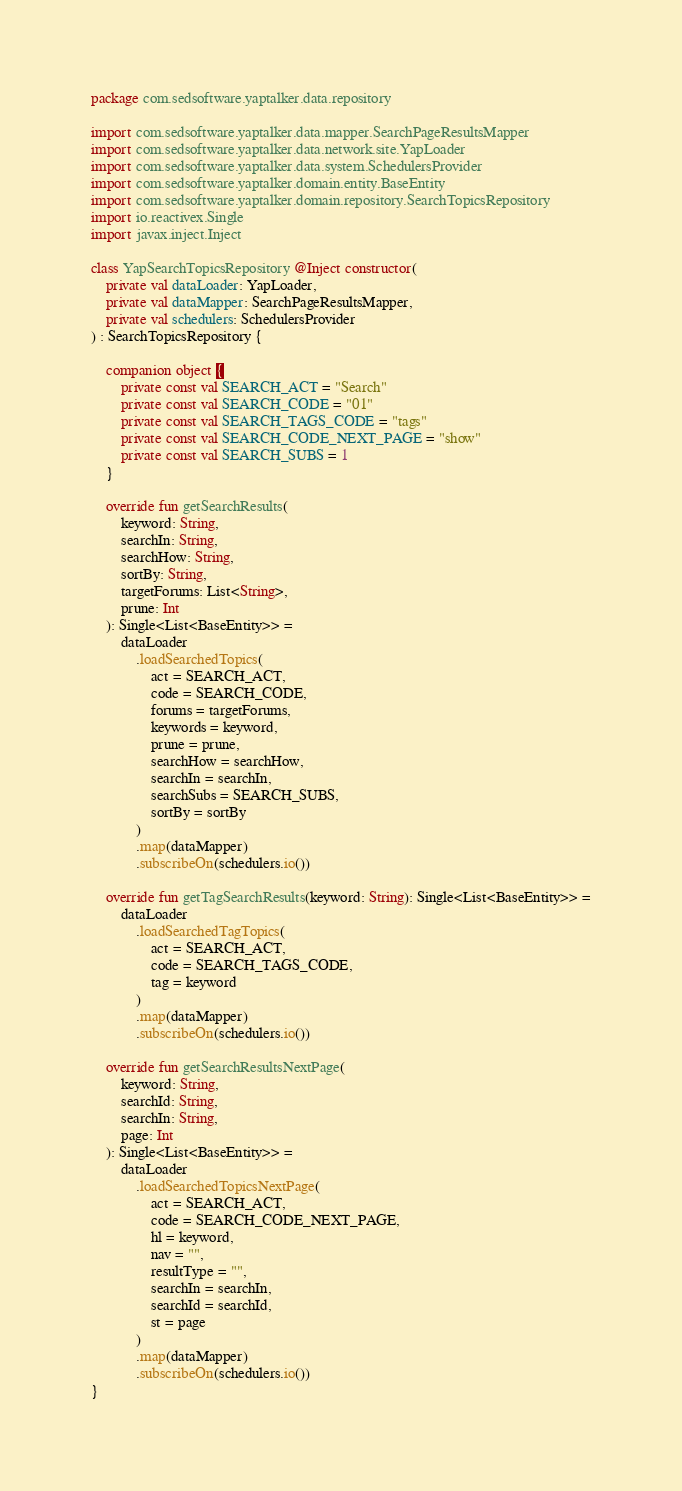<code> <loc_0><loc_0><loc_500><loc_500><_Kotlin_>package com.sedsoftware.yaptalker.data.repository

import com.sedsoftware.yaptalker.data.mapper.SearchPageResultsMapper
import com.sedsoftware.yaptalker.data.network.site.YapLoader
import com.sedsoftware.yaptalker.data.system.SchedulersProvider
import com.sedsoftware.yaptalker.domain.entity.BaseEntity
import com.sedsoftware.yaptalker.domain.repository.SearchTopicsRepository
import io.reactivex.Single
import javax.inject.Inject

class YapSearchTopicsRepository @Inject constructor(
    private val dataLoader: YapLoader,
    private val dataMapper: SearchPageResultsMapper,
    private val schedulers: SchedulersProvider
) : SearchTopicsRepository {

    companion object {
        private const val SEARCH_ACT = "Search"
        private const val SEARCH_CODE = "01"
        private const val SEARCH_TAGS_CODE = "tags"
        private const val SEARCH_CODE_NEXT_PAGE = "show"
        private const val SEARCH_SUBS = 1
    }

    override fun getSearchResults(
        keyword: String,
        searchIn: String,
        searchHow: String,
        sortBy: String,
        targetForums: List<String>,
        prune: Int
    ): Single<List<BaseEntity>> =
        dataLoader
            .loadSearchedTopics(
                act = SEARCH_ACT,
                code = SEARCH_CODE,
                forums = targetForums,
                keywords = keyword,
                prune = prune,
                searchHow = searchHow,
                searchIn = searchIn,
                searchSubs = SEARCH_SUBS,
                sortBy = sortBy
            )
            .map(dataMapper)
            .subscribeOn(schedulers.io())

    override fun getTagSearchResults(keyword: String): Single<List<BaseEntity>> =
        dataLoader
            .loadSearchedTagTopics(
                act = SEARCH_ACT,
                code = SEARCH_TAGS_CODE,
                tag = keyword
            )
            .map(dataMapper)
            .subscribeOn(schedulers.io())

    override fun getSearchResultsNextPage(
        keyword: String,
        searchId: String,
        searchIn: String,
        page: Int
    ): Single<List<BaseEntity>> =
        dataLoader
            .loadSearchedTopicsNextPage(
                act = SEARCH_ACT,
                code = SEARCH_CODE_NEXT_PAGE,
                hl = keyword,
                nav = "",
                resultType = "",
                searchIn = searchIn,
                searchId = searchId,
                st = page
            )
            .map(dataMapper)
            .subscribeOn(schedulers.io())
}
</code> 